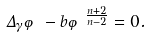<formula> <loc_0><loc_0><loc_500><loc_500>\Delta _ { \gamma } \varphi - b \varphi ^ { \frac { n + 2 } { n - 2 } } = 0 .</formula> 